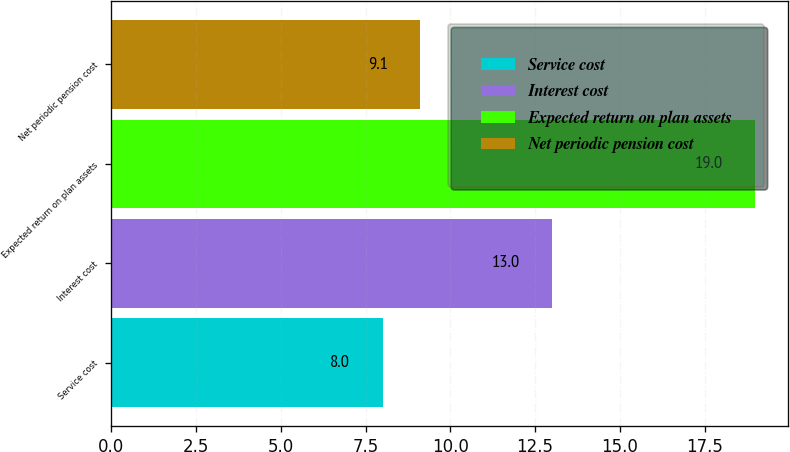Convert chart to OTSL. <chart><loc_0><loc_0><loc_500><loc_500><bar_chart><fcel>Service cost<fcel>Interest cost<fcel>Expected return on plan assets<fcel>Net periodic pension cost<nl><fcel>8<fcel>13<fcel>19<fcel>9.1<nl></chart> 